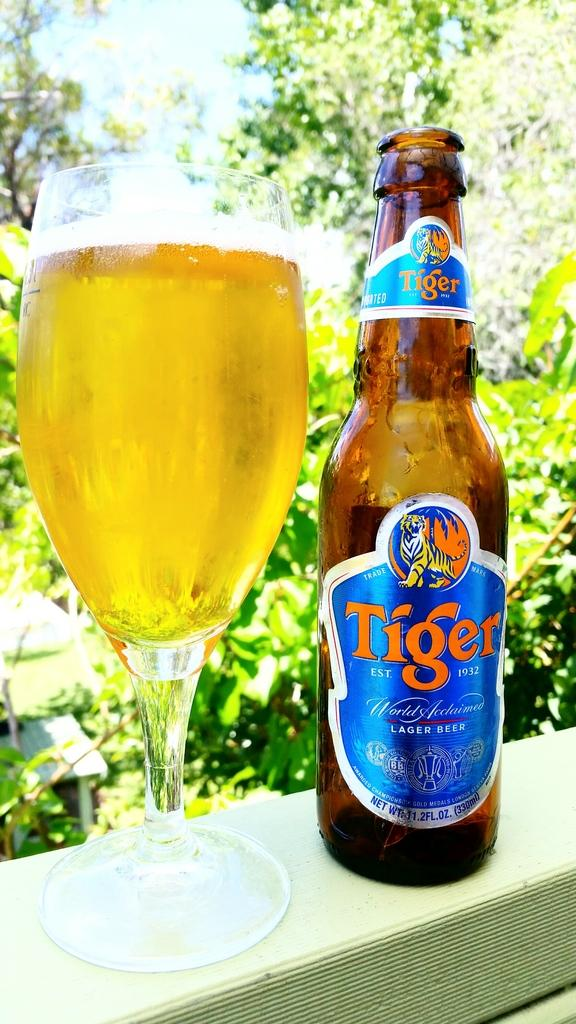<image>
Write a terse but informative summary of the picture. Bottle of Tiger beer next to a cup of beer. 